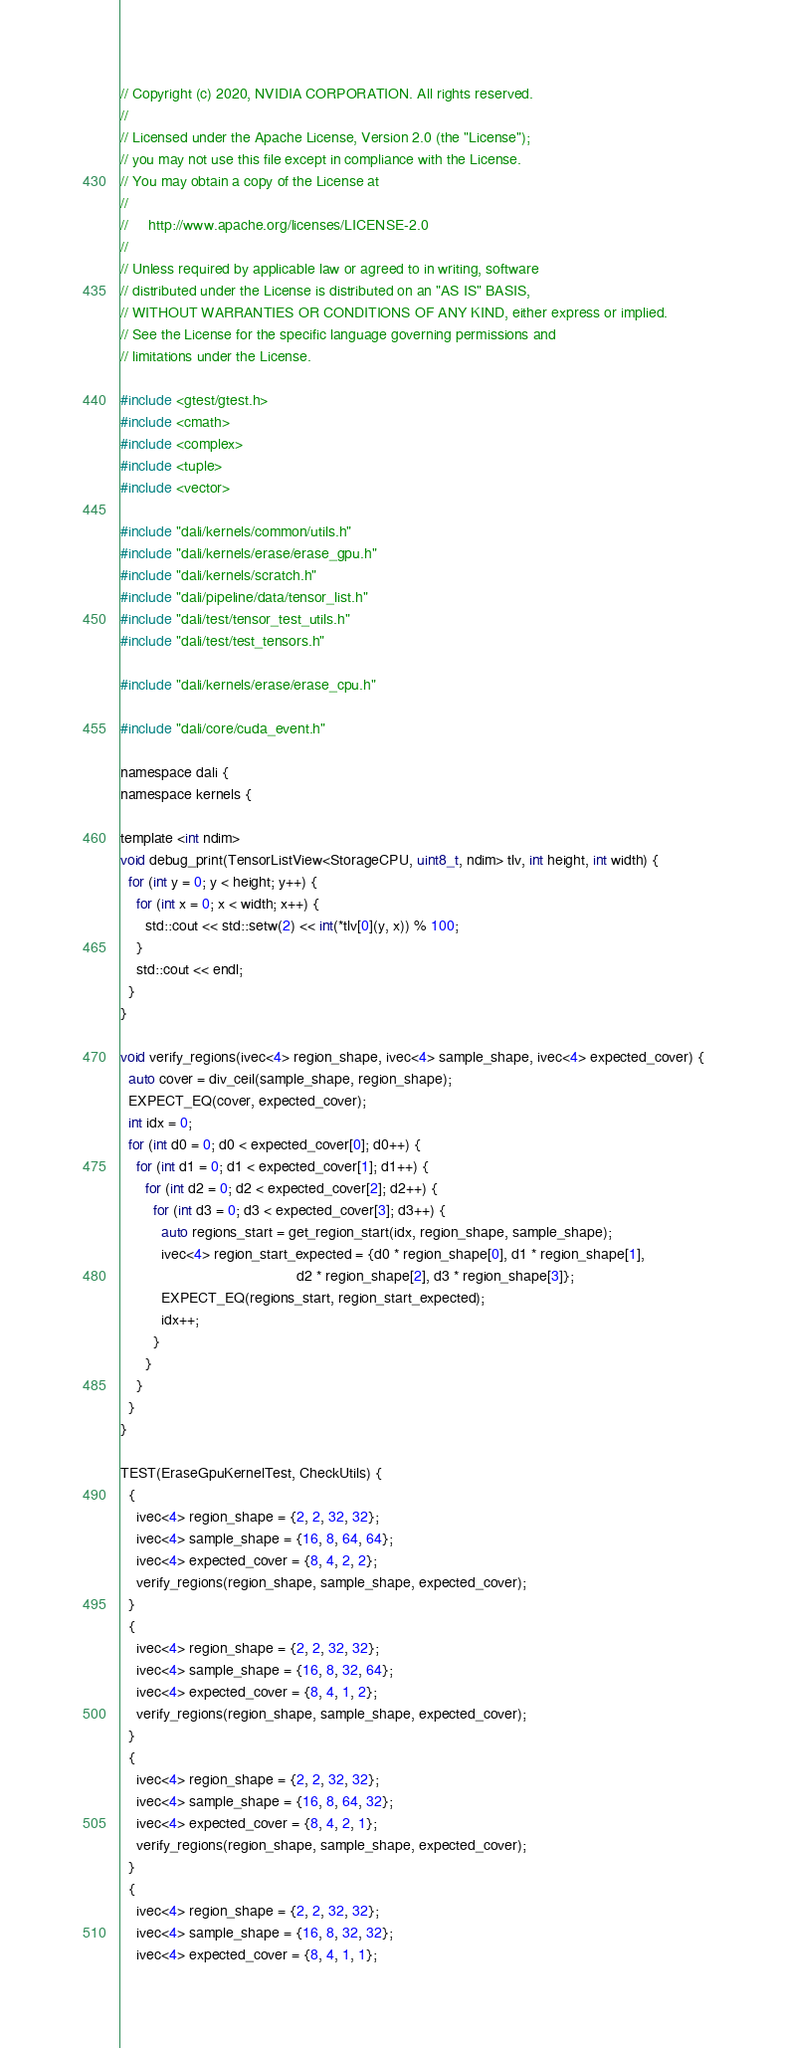<code> <loc_0><loc_0><loc_500><loc_500><_Cuda_>// Copyright (c) 2020, NVIDIA CORPORATION. All rights reserved.
//
// Licensed under the Apache License, Version 2.0 (the "License");
// you may not use this file except in compliance with the License.
// You may obtain a copy of the License at
//
//     http://www.apache.org/licenses/LICENSE-2.0
//
// Unless required by applicable law or agreed to in writing, software
// distributed under the License is distributed on an "AS IS" BASIS,
// WITHOUT WARRANTIES OR CONDITIONS OF ANY KIND, either express or implied.
// See the License for the specific language governing permissions and
// limitations under the License.

#include <gtest/gtest.h>
#include <cmath>
#include <complex>
#include <tuple>
#include <vector>

#include "dali/kernels/common/utils.h"
#include "dali/kernels/erase/erase_gpu.h"
#include "dali/kernels/scratch.h"
#include "dali/pipeline/data/tensor_list.h"
#include "dali/test/tensor_test_utils.h"
#include "dali/test/test_tensors.h"

#include "dali/kernels/erase/erase_cpu.h"

#include "dali/core/cuda_event.h"

namespace dali {
namespace kernels {

template <int ndim>
void debug_print(TensorListView<StorageCPU, uint8_t, ndim> tlv, int height, int width) {
  for (int y = 0; y < height; y++) {
    for (int x = 0; x < width; x++) {
      std::cout << std::setw(2) << int(*tlv[0](y, x)) % 100;
    }
    std::cout << endl;
  }
}

void verify_regions(ivec<4> region_shape, ivec<4> sample_shape, ivec<4> expected_cover) {
  auto cover = div_ceil(sample_shape, region_shape);
  EXPECT_EQ(cover, expected_cover);
  int idx = 0;
  for (int d0 = 0; d0 < expected_cover[0]; d0++) {
    for (int d1 = 0; d1 < expected_cover[1]; d1++) {
      for (int d2 = 0; d2 < expected_cover[2]; d2++) {
        for (int d3 = 0; d3 < expected_cover[3]; d3++) {
          auto regions_start = get_region_start(idx, region_shape, sample_shape);
          ivec<4> region_start_expected = {d0 * region_shape[0], d1 * region_shape[1],
                                           d2 * region_shape[2], d3 * region_shape[3]};
          EXPECT_EQ(regions_start, region_start_expected);
          idx++;
        }
      }
    }
  }
}

TEST(EraseGpuKernelTest, CheckUtils) {
  {
    ivec<4> region_shape = {2, 2, 32, 32};
    ivec<4> sample_shape = {16, 8, 64, 64};
    ivec<4> expected_cover = {8, 4, 2, 2};
    verify_regions(region_shape, sample_shape, expected_cover);
  }
  {
    ivec<4> region_shape = {2, 2, 32, 32};
    ivec<4> sample_shape = {16, 8, 32, 64};
    ivec<4> expected_cover = {8, 4, 1, 2};
    verify_regions(region_shape, sample_shape, expected_cover);
  }
  {
    ivec<4> region_shape = {2, 2, 32, 32};
    ivec<4> sample_shape = {16, 8, 64, 32};
    ivec<4> expected_cover = {8, 4, 2, 1};
    verify_regions(region_shape, sample_shape, expected_cover);
  }
  {
    ivec<4> region_shape = {2, 2, 32, 32};
    ivec<4> sample_shape = {16, 8, 32, 32};
    ivec<4> expected_cover = {8, 4, 1, 1};</code> 